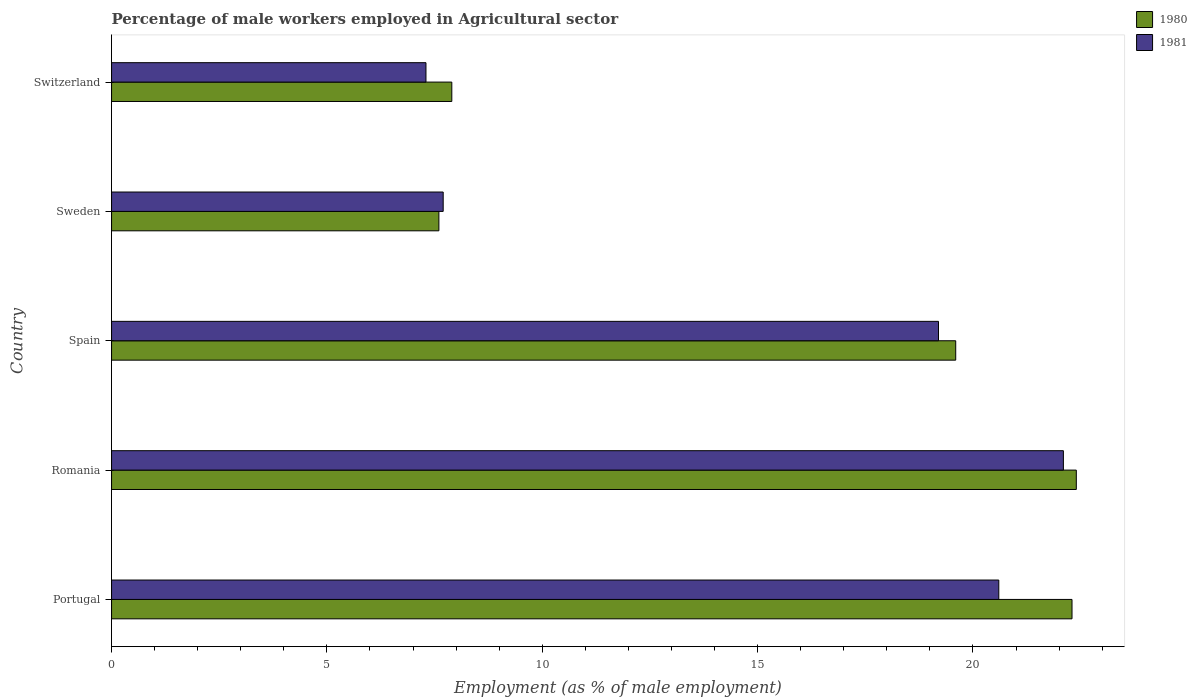How many groups of bars are there?
Offer a terse response. 5. How many bars are there on the 3rd tick from the top?
Ensure brevity in your answer.  2. What is the percentage of male workers employed in Agricultural sector in 1981 in Spain?
Make the answer very short. 19.2. Across all countries, what is the maximum percentage of male workers employed in Agricultural sector in 1980?
Make the answer very short. 22.4. Across all countries, what is the minimum percentage of male workers employed in Agricultural sector in 1981?
Offer a terse response. 7.3. In which country was the percentage of male workers employed in Agricultural sector in 1980 maximum?
Give a very brief answer. Romania. In which country was the percentage of male workers employed in Agricultural sector in 1981 minimum?
Keep it short and to the point. Switzerland. What is the total percentage of male workers employed in Agricultural sector in 1980 in the graph?
Give a very brief answer. 79.8. What is the difference between the percentage of male workers employed in Agricultural sector in 1981 in Portugal and that in Spain?
Your answer should be very brief. 1.4. What is the difference between the percentage of male workers employed in Agricultural sector in 1980 in Switzerland and the percentage of male workers employed in Agricultural sector in 1981 in Sweden?
Offer a terse response. 0.2. What is the average percentage of male workers employed in Agricultural sector in 1981 per country?
Your answer should be very brief. 15.38. What is the difference between the percentage of male workers employed in Agricultural sector in 1980 and percentage of male workers employed in Agricultural sector in 1981 in Portugal?
Provide a short and direct response. 1.7. In how many countries, is the percentage of male workers employed in Agricultural sector in 1980 greater than 5 %?
Your answer should be compact. 5. What is the ratio of the percentage of male workers employed in Agricultural sector in 1981 in Sweden to that in Switzerland?
Provide a succinct answer. 1.05. Is the percentage of male workers employed in Agricultural sector in 1981 in Portugal less than that in Sweden?
Make the answer very short. No. Is the difference between the percentage of male workers employed in Agricultural sector in 1980 in Sweden and Switzerland greater than the difference between the percentage of male workers employed in Agricultural sector in 1981 in Sweden and Switzerland?
Give a very brief answer. No. What is the difference between the highest and the second highest percentage of male workers employed in Agricultural sector in 1980?
Your response must be concise. 0.1. What is the difference between the highest and the lowest percentage of male workers employed in Agricultural sector in 1980?
Ensure brevity in your answer.  14.8. In how many countries, is the percentage of male workers employed in Agricultural sector in 1981 greater than the average percentage of male workers employed in Agricultural sector in 1981 taken over all countries?
Keep it short and to the point. 3. What does the 1st bar from the top in Switzerland represents?
Your response must be concise. 1981. How many bars are there?
Your answer should be compact. 10. Are all the bars in the graph horizontal?
Make the answer very short. Yes. Where does the legend appear in the graph?
Ensure brevity in your answer.  Top right. How are the legend labels stacked?
Provide a succinct answer. Vertical. What is the title of the graph?
Keep it short and to the point. Percentage of male workers employed in Agricultural sector. What is the label or title of the X-axis?
Provide a short and direct response. Employment (as % of male employment). What is the Employment (as % of male employment) in 1980 in Portugal?
Offer a terse response. 22.3. What is the Employment (as % of male employment) in 1981 in Portugal?
Your answer should be very brief. 20.6. What is the Employment (as % of male employment) of 1980 in Romania?
Your response must be concise. 22.4. What is the Employment (as % of male employment) of 1981 in Romania?
Your answer should be compact. 22.1. What is the Employment (as % of male employment) of 1980 in Spain?
Keep it short and to the point. 19.6. What is the Employment (as % of male employment) of 1981 in Spain?
Offer a very short reply. 19.2. What is the Employment (as % of male employment) of 1980 in Sweden?
Your response must be concise. 7.6. What is the Employment (as % of male employment) in 1981 in Sweden?
Your answer should be very brief. 7.7. What is the Employment (as % of male employment) of 1980 in Switzerland?
Your answer should be compact. 7.9. What is the Employment (as % of male employment) of 1981 in Switzerland?
Give a very brief answer. 7.3. Across all countries, what is the maximum Employment (as % of male employment) in 1980?
Give a very brief answer. 22.4. Across all countries, what is the maximum Employment (as % of male employment) of 1981?
Your response must be concise. 22.1. Across all countries, what is the minimum Employment (as % of male employment) in 1980?
Give a very brief answer. 7.6. Across all countries, what is the minimum Employment (as % of male employment) of 1981?
Provide a short and direct response. 7.3. What is the total Employment (as % of male employment) of 1980 in the graph?
Provide a succinct answer. 79.8. What is the total Employment (as % of male employment) of 1981 in the graph?
Your answer should be compact. 76.9. What is the difference between the Employment (as % of male employment) of 1980 in Portugal and that in Romania?
Make the answer very short. -0.1. What is the difference between the Employment (as % of male employment) of 1981 in Portugal and that in Romania?
Your answer should be compact. -1.5. What is the difference between the Employment (as % of male employment) of 1981 in Portugal and that in Sweden?
Give a very brief answer. 12.9. What is the difference between the Employment (as % of male employment) in 1981 in Portugal and that in Switzerland?
Your response must be concise. 13.3. What is the difference between the Employment (as % of male employment) of 1980 in Romania and that in Spain?
Give a very brief answer. 2.8. What is the difference between the Employment (as % of male employment) of 1980 in Romania and that in Sweden?
Offer a very short reply. 14.8. What is the difference between the Employment (as % of male employment) in 1981 in Romania and that in Sweden?
Provide a short and direct response. 14.4. What is the difference between the Employment (as % of male employment) of 1980 in Romania and that in Switzerland?
Your answer should be compact. 14.5. What is the difference between the Employment (as % of male employment) of 1981 in Romania and that in Switzerland?
Your answer should be very brief. 14.8. What is the difference between the Employment (as % of male employment) in 1980 in Spain and that in Sweden?
Your response must be concise. 12. What is the difference between the Employment (as % of male employment) of 1980 in Spain and that in Switzerland?
Offer a very short reply. 11.7. What is the difference between the Employment (as % of male employment) in 1981 in Sweden and that in Switzerland?
Your response must be concise. 0.4. What is the difference between the Employment (as % of male employment) of 1980 in Portugal and the Employment (as % of male employment) of 1981 in Spain?
Give a very brief answer. 3.1. What is the difference between the Employment (as % of male employment) of 1980 in Portugal and the Employment (as % of male employment) of 1981 in Sweden?
Provide a short and direct response. 14.6. What is the difference between the Employment (as % of male employment) of 1980 in Romania and the Employment (as % of male employment) of 1981 in Sweden?
Offer a very short reply. 14.7. What is the difference between the Employment (as % of male employment) in 1980 in Spain and the Employment (as % of male employment) in 1981 in Switzerland?
Give a very brief answer. 12.3. What is the average Employment (as % of male employment) of 1980 per country?
Your response must be concise. 15.96. What is the average Employment (as % of male employment) of 1981 per country?
Your answer should be very brief. 15.38. What is the difference between the Employment (as % of male employment) of 1980 and Employment (as % of male employment) of 1981 in Portugal?
Offer a very short reply. 1.7. What is the difference between the Employment (as % of male employment) in 1980 and Employment (as % of male employment) in 1981 in Switzerland?
Ensure brevity in your answer.  0.6. What is the ratio of the Employment (as % of male employment) in 1980 in Portugal to that in Romania?
Ensure brevity in your answer.  1. What is the ratio of the Employment (as % of male employment) in 1981 in Portugal to that in Romania?
Offer a terse response. 0.93. What is the ratio of the Employment (as % of male employment) of 1980 in Portugal to that in Spain?
Your response must be concise. 1.14. What is the ratio of the Employment (as % of male employment) in 1981 in Portugal to that in Spain?
Your answer should be very brief. 1.07. What is the ratio of the Employment (as % of male employment) of 1980 in Portugal to that in Sweden?
Offer a very short reply. 2.93. What is the ratio of the Employment (as % of male employment) of 1981 in Portugal to that in Sweden?
Give a very brief answer. 2.68. What is the ratio of the Employment (as % of male employment) of 1980 in Portugal to that in Switzerland?
Your answer should be compact. 2.82. What is the ratio of the Employment (as % of male employment) of 1981 in Portugal to that in Switzerland?
Your response must be concise. 2.82. What is the ratio of the Employment (as % of male employment) in 1981 in Romania to that in Spain?
Give a very brief answer. 1.15. What is the ratio of the Employment (as % of male employment) in 1980 in Romania to that in Sweden?
Provide a short and direct response. 2.95. What is the ratio of the Employment (as % of male employment) of 1981 in Romania to that in Sweden?
Offer a terse response. 2.87. What is the ratio of the Employment (as % of male employment) of 1980 in Romania to that in Switzerland?
Ensure brevity in your answer.  2.84. What is the ratio of the Employment (as % of male employment) in 1981 in Romania to that in Switzerland?
Your response must be concise. 3.03. What is the ratio of the Employment (as % of male employment) in 1980 in Spain to that in Sweden?
Your response must be concise. 2.58. What is the ratio of the Employment (as % of male employment) of 1981 in Spain to that in Sweden?
Provide a short and direct response. 2.49. What is the ratio of the Employment (as % of male employment) of 1980 in Spain to that in Switzerland?
Provide a short and direct response. 2.48. What is the ratio of the Employment (as % of male employment) in 1981 in Spain to that in Switzerland?
Your answer should be compact. 2.63. What is the ratio of the Employment (as % of male employment) of 1981 in Sweden to that in Switzerland?
Your response must be concise. 1.05. What is the difference between the highest and the second highest Employment (as % of male employment) in 1980?
Offer a terse response. 0.1. What is the difference between the highest and the lowest Employment (as % of male employment) in 1980?
Ensure brevity in your answer.  14.8. What is the difference between the highest and the lowest Employment (as % of male employment) of 1981?
Give a very brief answer. 14.8. 